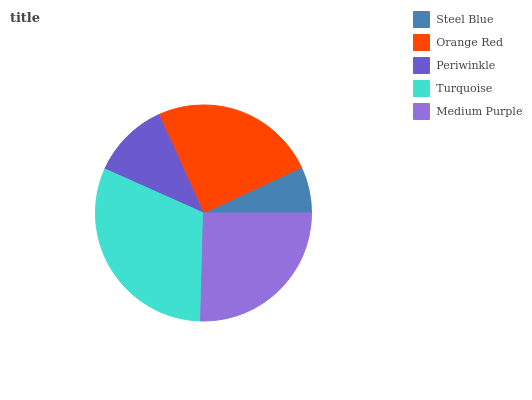Is Steel Blue the minimum?
Answer yes or no. Yes. Is Turquoise the maximum?
Answer yes or no. Yes. Is Orange Red the minimum?
Answer yes or no. No. Is Orange Red the maximum?
Answer yes or no. No. Is Orange Red greater than Steel Blue?
Answer yes or no. Yes. Is Steel Blue less than Orange Red?
Answer yes or no. Yes. Is Steel Blue greater than Orange Red?
Answer yes or no. No. Is Orange Red less than Steel Blue?
Answer yes or no. No. Is Orange Red the high median?
Answer yes or no. Yes. Is Orange Red the low median?
Answer yes or no. Yes. Is Medium Purple the high median?
Answer yes or no. No. Is Periwinkle the low median?
Answer yes or no. No. 